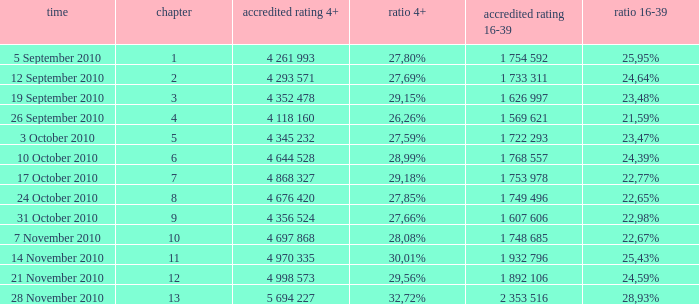What is the 16-39 share of the episode with a 4+ share of 30,01%? 25,43%. 